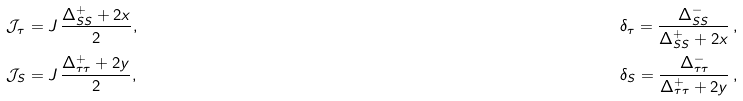Convert formula to latex. <formula><loc_0><loc_0><loc_500><loc_500>\mathcal { J } _ { \tau } & = J \, \frac { \Delta ^ { + } _ { S S } + 2 x } { 2 } , & \quad \delta _ { \tau } = \frac { \Delta _ { S S } ^ { - } } { \Delta _ { S S } ^ { + } + 2 x } \, , \\ \mathcal { J } _ { S } & = J \, \frac { \Delta ^ { + } _ { \tau \tau } + 2 y } { 2 } , & \quad \delta _ { S } = \frac { \Delta _ { \tau \tau } ^ { - } } { \Delta _ { \tau \tau } ^ { + } + 2 y } \, ,</formula> 